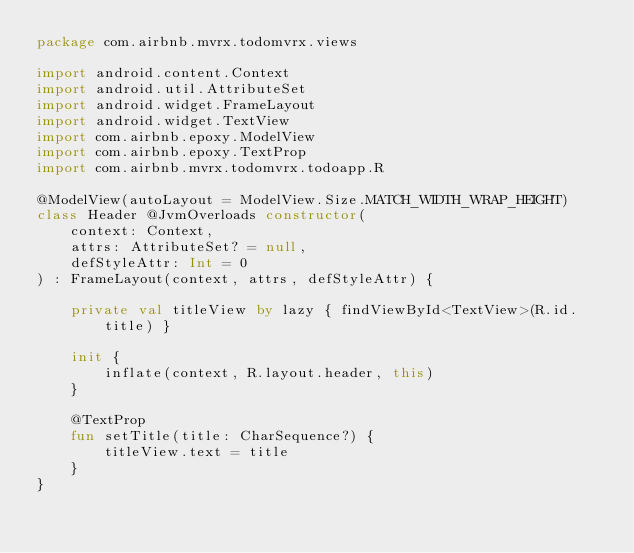Convert code to text. <code><loc_0><loc_0><loc_500><loc_500><_Kotlin_>package com.airbnb.mvrx.todomvrx.views

import android.content.Context
import android.util.AttributeSet
import android.widget.FrameLayout
import android.widget.TextView
import com.airbnb.epoxy.ModelView
import com.airbnb.epoxy.TextProp
import com.airbnb.mvrx.todomvrx.todoapp.R

@ModelView(autoLayout = ModelView.Size.MATCH_WIDTH_WRAP_HEIGHT)
class Header @JvmOverloads constructor(
    context: Context,
    attrs: AttributeSet? = null,
    defStyleAttr: Int = 0
) : FrameLayout(context, attrs, defStyleAttr) {

    private val titleView by lazy { findViewById<TextView>(R.id.title) }

    init {
        inflate(context, R.layout.header, this)
    }

    @TextProp
    fun setTitle(title: CharSequence?) {
        titleView.text = title
    }
}
</code> 